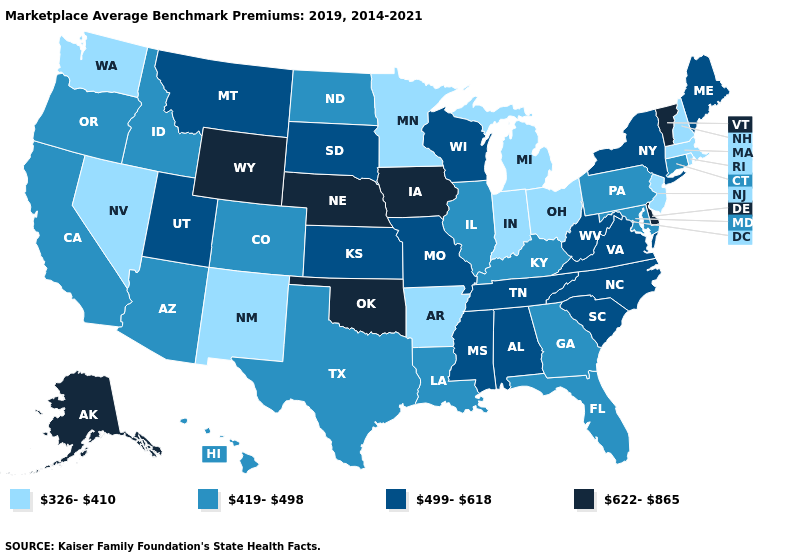Does the first symbol in the legend represent the smallest category?
Write a very short answer. Yes. Does Mississippi have the highest value in the South?
Give a very brief answer. No. Does New Hampshire have the same value as Utah?
Short answer required. No. Name the states that have a value in the range 419-498?
Be succinct. Arizona, California, Colorado, Connecticut, Florida, Georgia, Hawaii, Idaho, Illinois, Kentucky, Louisiana, Maryland, North Dakota, Oregon, Pennsylvania, Texas. Which states have the lowest value in the USA?
Be succinct. Arkansas, Indiana, Massachusetts, Michigan, Minnesota, Nevada, New Hampshire, New Jersey, New Mexico, Ohio, Rhode Island, Washington. Name the states that have a value in the range 419-498?
Write a very short answer. Arizona, California, Colorado, Connecticut, Florida, Georgia, Hawaii, Idaho, Illinois, Kentucky, Louisiana, Maryland, North Dakota, Oregon, Pennsylvania, Texas. Name the states that have a value in the range 419-498?
Answer briefly. Arizona, California, Colorado, Connecticut, Florida, Georgia, Hawaii, Idaho, Illinois, Kentucky, Louisiana, Maryland, North Dakota, Oregon, Pennsylvania, Texas. Which states have the lowest value in the Northeast?
Keep it brief. Massachusetts, New Hampshire, New Jersey, Rhode Island. What is the value of Hawaii?
Keep it brief. 419-498. Does the first symbol in the legend represent the smallest category?
Be succinct. Yes. What is the highest value in states that border Montana?
Keep it brief. 622-865. Name the states that have a value in the range 326-410?
Concise answer only. Arkansas, Indiana, Massachusetts, Michigan, Minnesota, Nevada, New Hampshire, New Jersey, New Mexico, Ohio, Rhode Island, Washington. Name the states that have a value in the range 326-410?
Give a very brief answer. Arkansas, Indiana, Massachusetts, Michigan, Minnesota, Nevada, New Hampshire, New Jersey, New Mexico, Ohio, Rhode Island, Washington. Which states have the lowest value in the South?
Give a very brief answer. Arkansas. Name the states that have a value in the range 419-498?
Quick response, please. Arizona, California, Colorado, Connecticut, Florida, Georgia, Hawaii, Idaho, Illinois, Kentucky, Louisiana, Maryland, North Dakota, Oregon, Pennsylvania, Texas. 